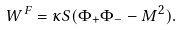Convert formula to latex. <formula><loc_0><loc_0><loc_500><loc_500>W ^ { F } = \kappa S ( \Phi _ { + } \Phi _ { - } - M ^ { 2 } ) .</formula> 